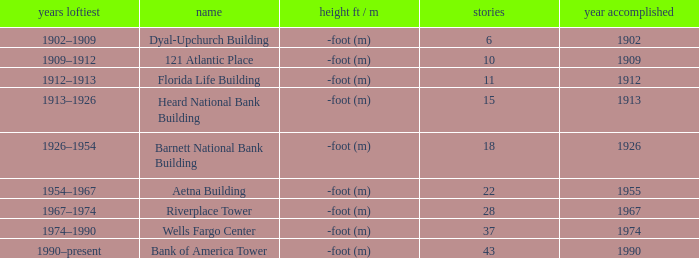What was the name of the building with 10 floors? 121 Atlantic Place. 